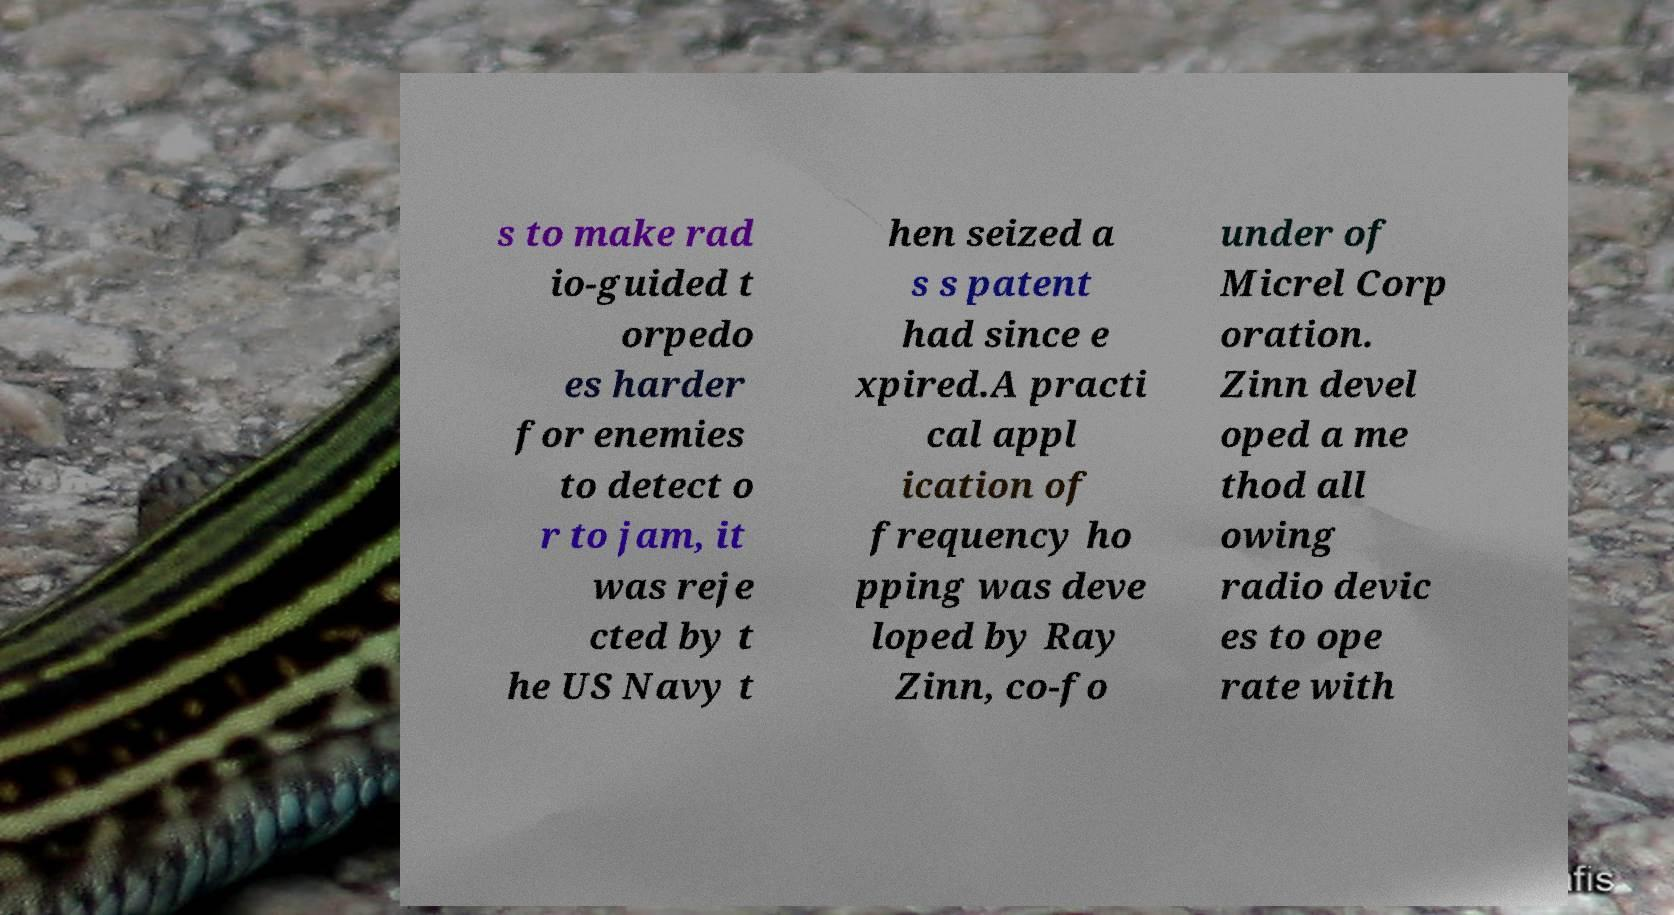I need the written content from this picture converted into text. Can you do that? s to make rad io-guided t orpedo es harder for enemies to detect o r to jam, it was reje cted by t he US Navy t hen seized a s s patent had since e xpired.A practi cal appl ication of frequency ho pping was deve loped by Ray Zinn, co-fo under of Micrel Corp oration. Zinn devel oped a me thod all owing radio devic es to ope rate with 